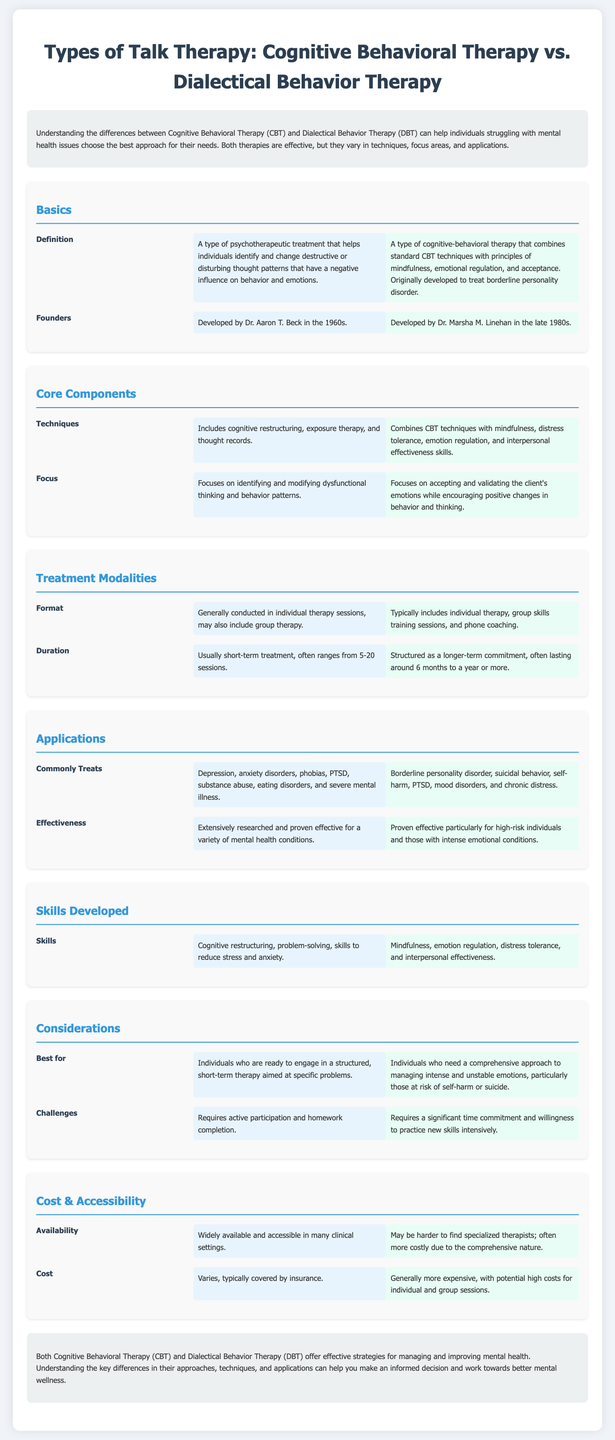What is the founder of CBT? The founder of CBT is Dr. Aaron T. Beck, who developed it in the 1960s.
Answer: Dr. Aaron T. Beck What techniques are included in DBT? DBT combines CBT techniques with mindfulness, distress tolerance, emotion regulation, and interpersonal effectiveness skills.
Answer: Mindfulness, distress tolerance, emotion regulation, and interpersonal effectiveness How long does CBT typically last? CBT is usually a short-term treatment, often ranging from 5-20 sessions.
Answer: 5-20 sessions What is the primary focus of DBT? DBT focuses on accepting and validating the client's emotions while encouraging positive changes in behavior and thinking.
Answer: Accepting and validating emotions Which therapy is best for individuals at risk of self-harm? DBT is best for individuals who need a comprehensive approach to managing intense and unstable emotions, particularly those at risk of self-harm or suicide.
Answer: DBT What are common conditions treated by CBT? CBT commonly treats depression, anxiety disorders, phobias, PTSD, substance abuse, eating disorders, and severe mental illness.
Answer: Depression, anxiety disorders, phobias, PTSD, substance abuse, eating disorders, and severe mental illness How many therapists typically conduct DBT sessions? DBT typically includes individual therapy, group skills training sessions, and phone coaching.
Answer: Individual, group, and phone coaching What type of therapy is DBT originally developed to treat? DBT was originally developed to treat borderline personality disorder.
Answer: Borderline personality disorder What is the cost of CBT compared to DBT? CBT generally varies, typically covered by insurance, while DBT is generally more expensive with potential high costs for individual and group sessions.
Answer: CBT is typically covered by insurance; DBT is generally more expensive 